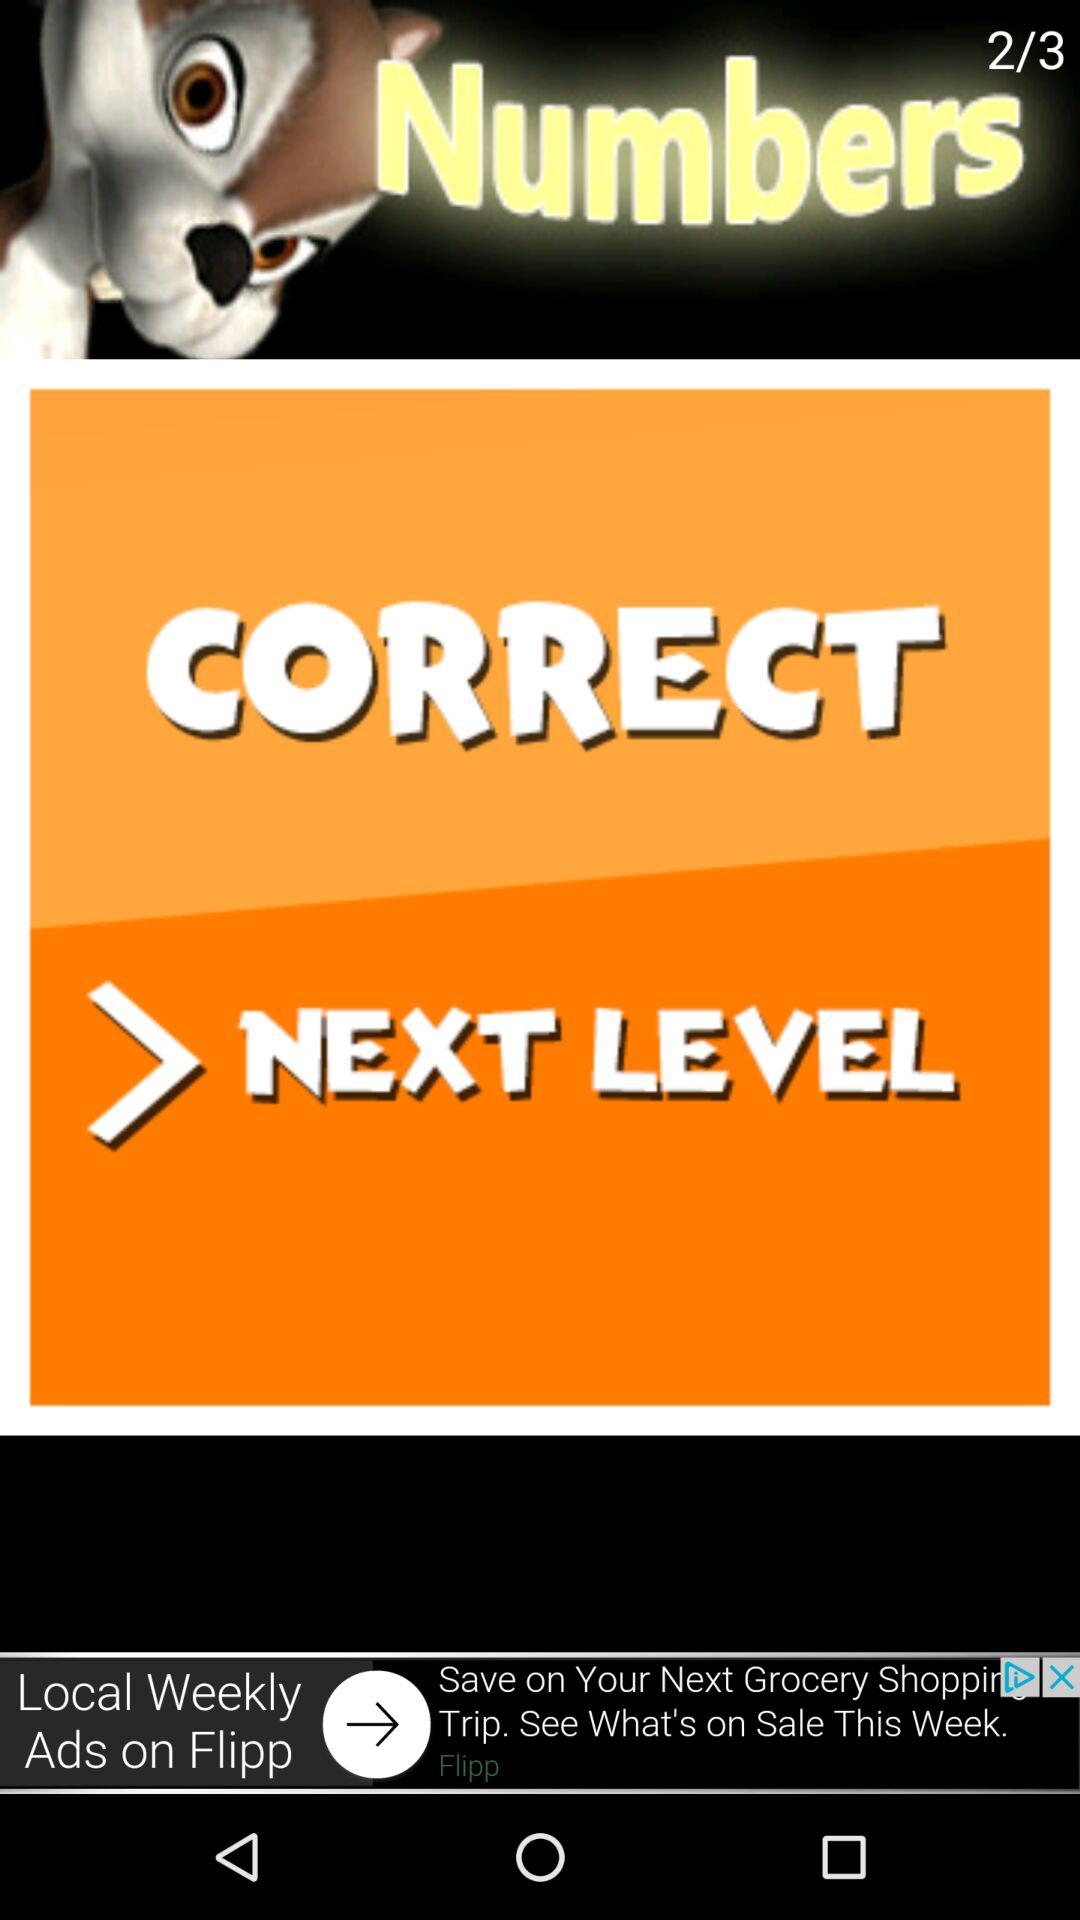What level am I at? Yor are at level 2. 